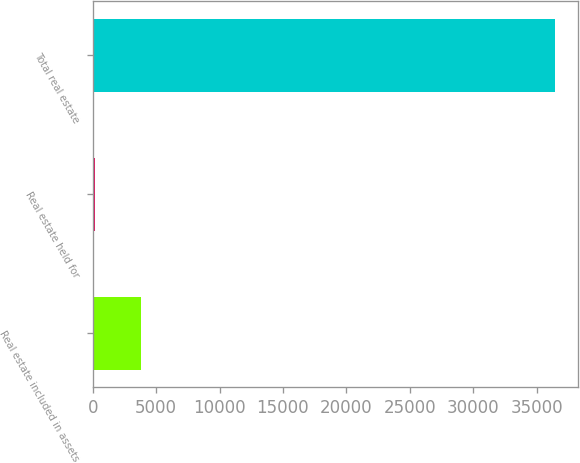<chart> <loc_0><loc_0><loc_500><loc_500><bar_chart><fcel>Real estate included in assets<fcel>Real estate held for<fcel>Total real estate<nl><fcel>3791<fcel>162<fcel>36452<nl></chart> 